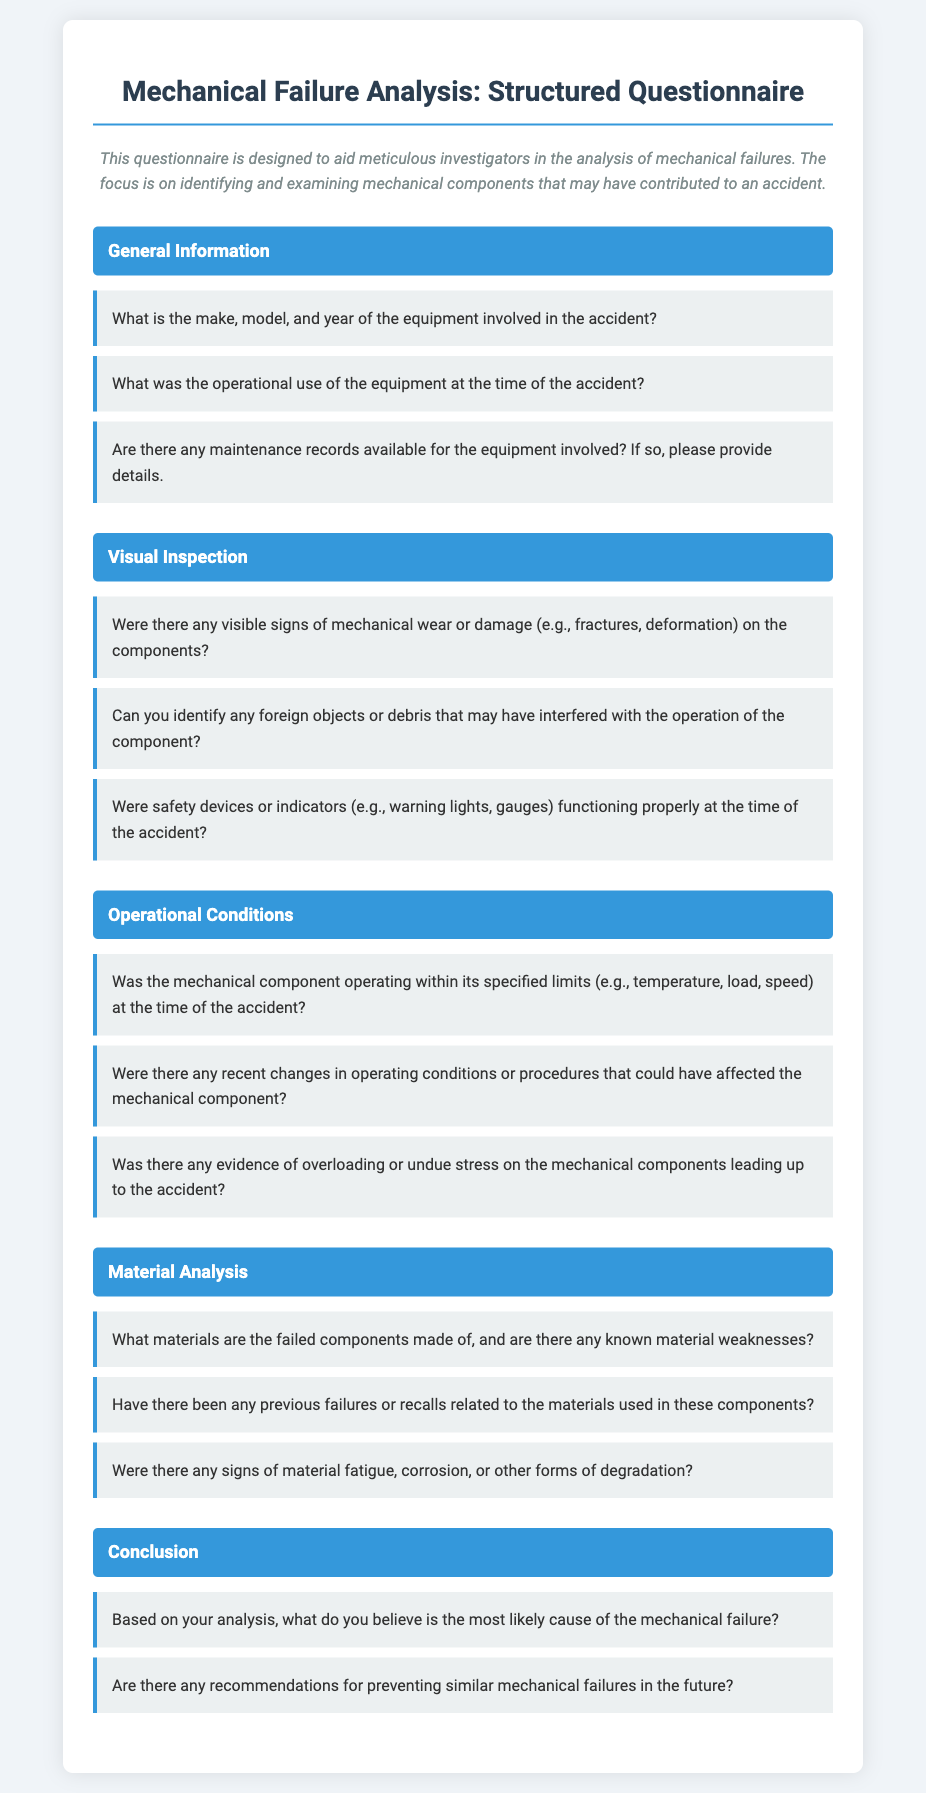What is the title of the document? The title of the document is prominently displayed at the top, indicating its purpose.
Answer: Mechanical Failure Analysis: Structured Questionnaire What is the purpose of the questionnaire? The purpose of the questionnaire is clearly stated in the introductory paragraph.
Answer: To aid meticulous investigators in the analysis of mechanical failures How many sections are included in the questionnaire? The document is divided into distinct sections to organize the questions effectively.
Answer: Five What types of conditions are evaluated in the 'Operational Conditions' section? The document specifies what aspects of operational conditions are assessed.
Answer: Specified limits, changes, evidence of overloading What is one recommendation type mentioned in the 'Conclusion' section? The document lists recommendations aiming to prevent future issues.
Answer: Preventing similar mechanical failures What does the 'Material Analysis' section ask about component materials? The questionnaire seeks specific information regarding materials used in components.
Answer: Known material weaknesses What is the question related to maintenance records? The document includes a question focusing on the availability of historical information.
Answer: Are there any maintenance records available for the equipment involved? What type of inspection is addressed in the second section? The section title indicates the focus area of the questions asked.
Answer: Visual Inspection What is queried regarding the operating limits of the mechanical component? The document inquires if the component's operation adhered to predefined parameters.
Answer: Was the mechanical component operating within its specified limits? 